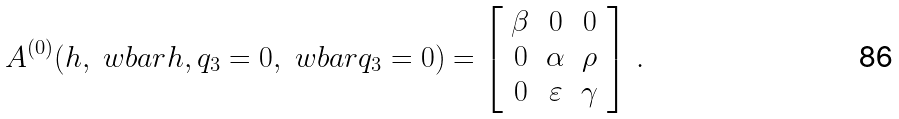<formula> <loc_0><loc_0><loc_500><loc_500>A ^ { ( 0 ) } ( h , \ w b a r { h } , q _ { 3 } = 0 , \ w b a r { q } _ { 3 } = 0 ) = \left [ \begin{array} { c c c } \beta & 0 & 0 \\ 0 & \alpha & \rho \\ 0 & \varepsilon & \gamma \end{array} \right ] \, .</formula> 